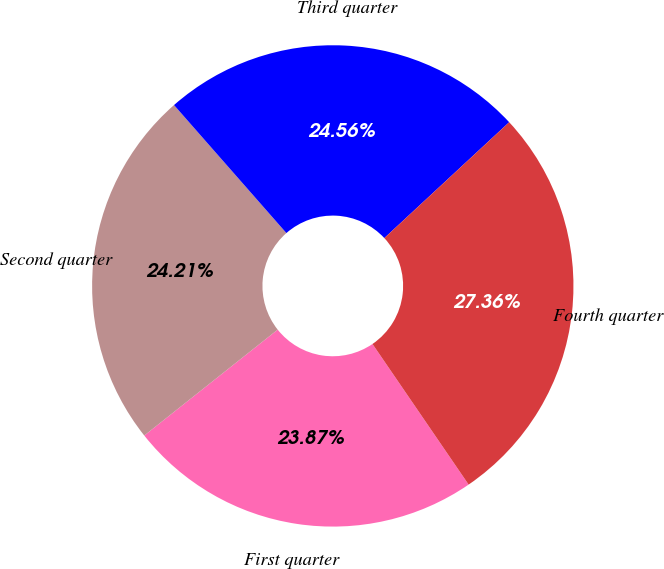Convert chart. <chart><loc_0><loc_0><loc_500><loc_500><pie_chart><fcel>First quarter<fcel>Second quarter<fcel>Third quarter<fcel>Fourth quarter<nl><fcel>23.87%<fcel>24.21%<fcel>24.56%<fcel>27.36%<nl></chart> 